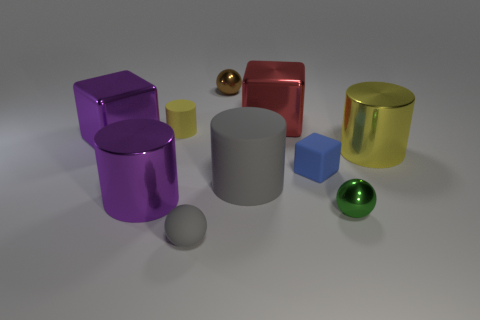There is a yellow object behind the large yellow metallic object; is its shape the same as the small gray rubber object?
Ensure brevity in your answer.  No. Is the number of shiny spheres that are on the right side of the small blue thing less than the number of matte spheres that are behind the tiny gray matte ball?
Your response must be concise. No. What material is the big yellow cylinder?
Make the answer very short. Metal. Is the color of the tiny rubber cylinder the same as the big shiny block that is behind the big purple metal cube?
Your answer should be compact. No. There is a big red metallic block; what number of big rubber cylinders are in front of it?
Offer a very short reply. 1. Are there fewer small green spheres behind the tiny yellow cylinder than small metallic things?
Offer a very short reply. Yes. The tiny rubber ball is what color?
Provide a short and direct response. Gray. There is a large cylinder on the left side of the big gray matte object; is its color the same as the matte cube?
Ensure brevity in your answer.  No. What color is the other metallic object that is the same shape as the large yellow metal object?
Ensure brevity in your answer.  Purple. How many big things are either blue matte things or gray balls?
Offer a very short reply. 0. 